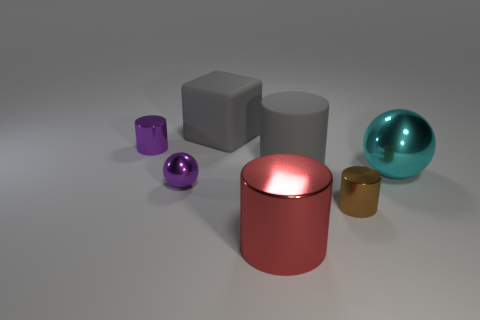Apart from their colors, how do the textures of the objects compare? The objects exhibit a variety of textures. The larger cylinder has a smooth and shiny surface, which reflects light clearly, indicating a high-gloss finish. The sphere also has a shiny appearance but seems to have a slightly less reflective surface than the cylinder. The cube and the small canister appear to have a matte finish with far less reflectivity. 